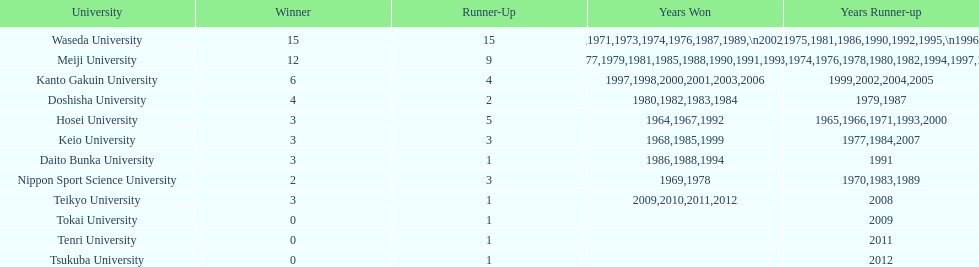Who won the last championship recorded on this table? Teikyo University. 